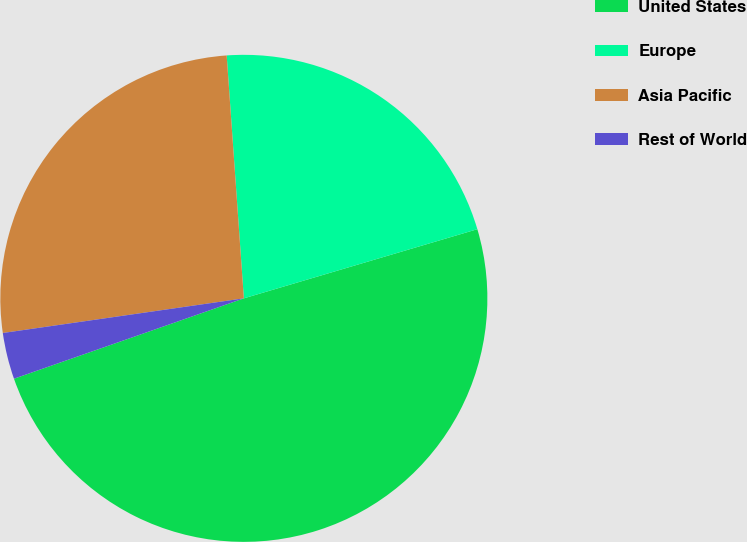Convert chart to OTSL. <chart><loc_0><loc_0><loc_500><loc_500><pie_chart><fcel>United States<fcel>Europe<fcel>Asia Pacific<fcel>Rest of World<nl><fcel>49.23%<fcel>21.54%<fcel>26.15%<fcel>3.08%<nl></chart> 